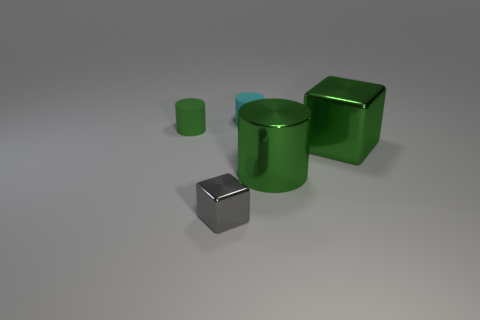How many tiny cyan things are made of the same material as the small green object?
Your answer should be very brief. 1. There is a rubber object that is the same color as the large block; what is its shape?
Your response must be concise. Cylinder. Are there an equal number of large green metallic blocks that are in front of the green shiny cylinder and big green rubber blocks?
Ensure brevity in your answer.  Yes. There is a green cylinder that is on the right side of the tiny green matte thing; how big is it?
Your response must be concise. Large. What number of small objects are green balls or green cubes?
Offer a very short reply. 0. There is another small matte thing that is the same shape as the green matte object; what color is it?
Your answer should be compact. Cyan. Does the green metallic cube have the same size as the gray block?
Provide a succinct answer. No. How many objects are tiny things or small rubber cylinders on the left side of the cyan cylinder?
Provide a succinct answer. 3. What color is the cylinder in front of the metallic cube that is on the right side of the tiny cyan cylinder?
Your response must be concise. Green. Do the cylinder in front of the green rubber object and the big metal cube have the same color?
Provide a short and direct response. Yes. 